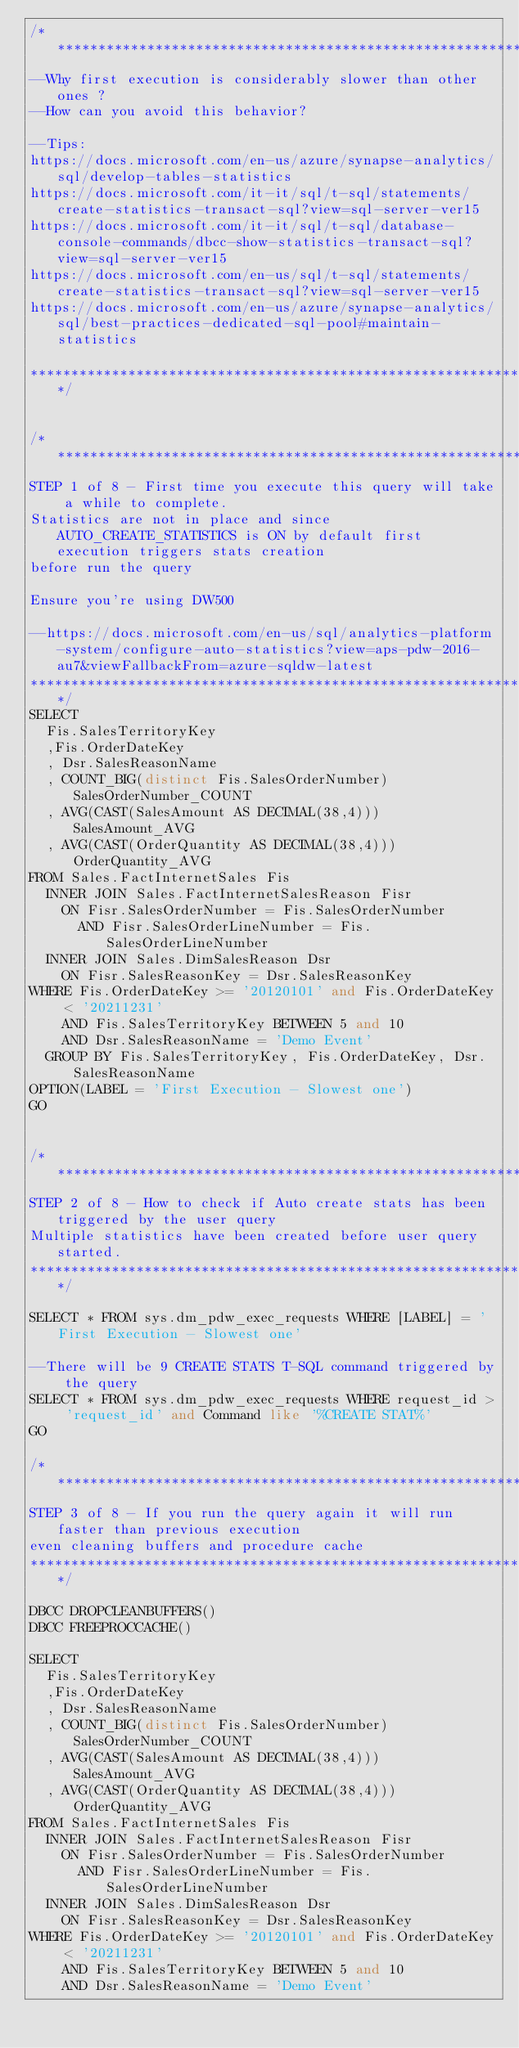<code> <loc_0><loc_0><loc_500><loc_500><_SQL_>/****************************************************************************************
--Why first execution is considerably slower than other ones ?
--How can you avoid this behavior?

--Tips:
https://docs.microsoft.com/en-us/azure/synapse-analytics/sql/develop-tables-statistics
https://docs.microsoft.com/it-it/sql/t-sql/statements/create-statistics-transact-sql?view=sql-server-ver15
https://docs.microsoft.com/it-it/sql/t-sql/database-console-commands/dbcc-show-statistics-transact-sql?view=sql-server-ver15
https://docs.microsoft.com/en-us/sql/t-sql/statements/create-statistics-transact-sql?view=sql-server-ver15
https://docs.microsoft.com/en-us/azure/synapse-analytics/sql/best-practices-dedicated-sql-pool#maintain-statistics

****************************************************************************************/


/***************************************************************************************
STEP 1 of 8 - First time you execute this query will take a while to complete.
Statistics are not in place and since AUTO_CREATE_STATISTICS is ON by default first execution triggers stats creation
before run the query

Ensure you're using DW500

--https://docs.microsoft.com/en-us/sql/analytics-platform-system/configure-auto-statistics?view=aps-pdw-2016-au7&viewFallbackFrom=azure-sqldw-latest
****************************************************************************************/
SELECT 
	Fis.SalesTerritoryKey
	,Fis.OrderDateKey
	, Dsr.SalesReasonName
	, COUNT_BIG(distinct Fis.SalesOrderNumber) SalesOrderNumber_COUNT
	, AVG(CAST(SalesAmount AS DECIMAL(38,4))) SalesAmount_AVG
	, AVG(CAST(OrderQuantity AS DECIMAL(38,4))) OrderQuantity_AVG
FROM Sales.FactInternetSales Fis
	INNER JOIN Sales.FactInternetSalesReason Fisr
		ON Fisr.SalesOrderNumber = Fis.SalesOrderNumber
			AND Fisr.SalesOrderLineNumber = Fis.SalesOrderLineNumber
	INNER JOIN Sales.DimSalesReason Dsr
		ON Fisr.SalesReasonKey = Dsr.SalesReasonKey
WHERE Fis.OrderDateKey >= '20120101' and Fis.OrderDateKey < '20211231'
		AND Fis.SalesTerritoryKey BETWEEN 5 and 10
		AND Dsr.SalesReasonName = 'Demo Event'
	GROUP BY Fis.SalesTerritoryKey, Fis.OrderDateKey, Dsr.SalesReasonName
OPTION(LABEL = 'First Execution - Slowest one')
GO


/***************************************************************************************
STEP 2 of 8 - How to check if Auto create stats has been triggered by the user query
Multiple statistics have been created before user query started.
****************************************************************************************/

SELECT * FROM sys.dm_pdw_exec_requests WHERE [LABEL] = 'First Execution - Slowest one'

--There will be 9 CREATE STATS T-SQL command triggered by the query
SELECT * FROM sys.dm_pdw_exec_requests WHERE request_id > 'request_id' and Command like '%CREATE STAT%'
GO

/***************************************************************************************
STEP 3 of 8 - If you run the query again it will run faster than previous execution 
even cleaning buffers and procedure cache
****************************************************************************************/

DBCC DROPCLEANBUFFERS()
DBCC FREEPROCCACHE()

SELECT 
	Fis.SalesTerritoryKey
	,Fis.OrderDateKey
	, Dsr.SalesReasonName
	, COUNT_BIG(distinct Fis.SalesOrderNumber) SalesOrderNumber_COUNT
	, AVG(CAST(SalesAmount AS DECIMAL(38,4))) SalesAmount_AVG
	, AVG(CAST(OrderQuantity AS DECIMAL(38,4))) OrderQuantity_AVG
FROM Sales.FactInternetSales Fis
	INNER JOIN Sales.FactInternetSalesReason Fisr
		ON Fisr.SalesOrderNumber = Fis.SalesOrderNumber
			AND Fisr.SalesOrderLineNumber = Fis.SalesOrderLineNumber
	INNER JOIN Sales.DimSalesReason Dsr
		ON Fisr.SalesReasonKey = Dsr.SalesReasonKey
WHERE Fis.OrderDateKey >= '20120101' and Fis.OrderDateKey < '20211231'
		AND Fis.SalesTerritoryKey BETWEEN 5 and 10
		AND Dsr.SalesReasonName = 'Demo Event'</code> 